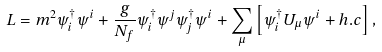<formula> <loc_0><loc_0><loc_500><loc_500>L = m ^ { 2 } \psi ^ { \dagger } _ { i } \psi ^ { i } + \frac { g } { N _ { f } } \psi ^ { \dagger } _ { i } \psi ^ { j } \psi ^ { \dagger } _ { j } \psi ^ { i } + \sum _ { \mu } \left [ \psi ^ { \dagger } _ { i } U _ { \mu } \psi ^ { i } + h . c \right ] ,</formula> 